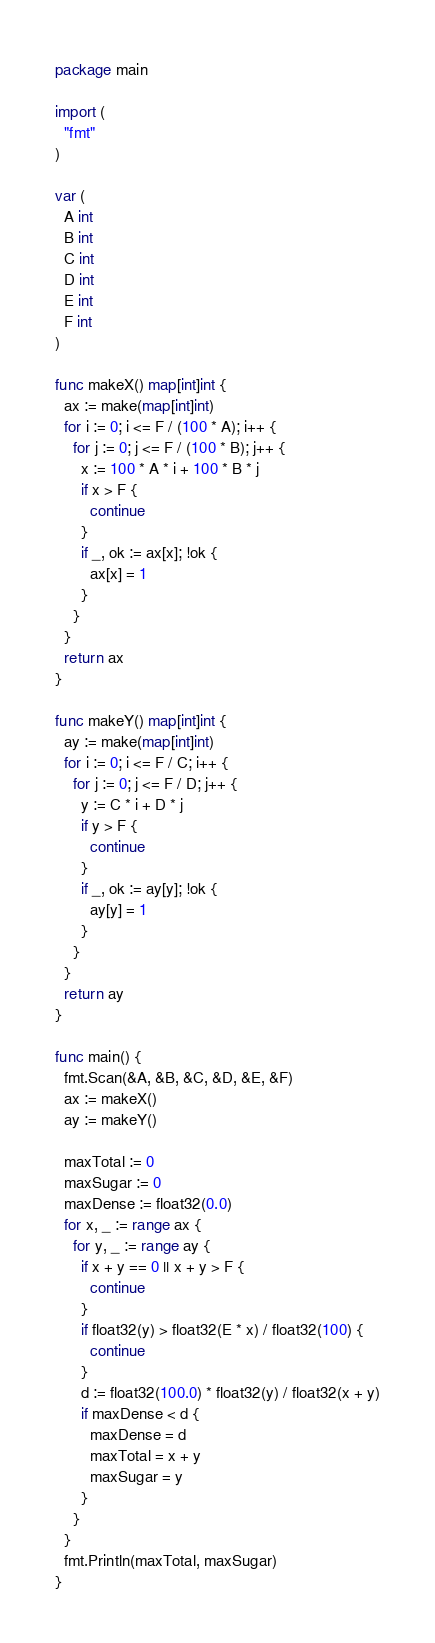Convert code to text. <code><loc_0><loc_0><loc_500><loc_500><_Go_>package main

import (
  "fmt"
)

var (
  A int
  B int
  C int
  D int
  E int
  F int
)

func makeX() map[int]int {
  ax := make(map[int]int)
  for i := 0; i <= F / (100 * A); i++ {
    for j := 0; j <= F / (100 * B); j++ {
      x := 100 * A * i + 100 * B * j
      if x > F {
        continue
      }
      if _, ok := ax[x]; !ok {
        ax[x] = 1
      }
    }
  }
  return ax
}

func makeY() map[int]int {
  ay := make(map[int]int)
  for i := 0; i <= F / C; i++ {
    for j := 0; j <= F / D; j++ {
      y := C * i + D * j
      if y > F {
        continue
      }
      if _, ok := ay[y]; !ok {
        ay[y] = 1
      }
    }
  }
  return ay
}

func main() {
  fmt.Scan(&A, &B, &C, &D, &E, &F)
  ax := makeX()
  ay := makeY()

  maxTotal := 0
  maxSugar := 0
  maxDense := float32(0.0)
  for x, _ := range ax {
    for y, _ := range ay {
      if x + y == 0 || x + y > F {
        continue
      }
      if float32(y) > float32(E * x) / float32(100) {
        continue
      }
      d := float32(100.0) * float32(y) / float32(x + y)
      if maxDense < d {
        maxDense = d
        maxTotal = x + y
        maxSugar = y
      }
    }
  }
  fmt.Println(maxTotal, maxSugar)
}
</code> 